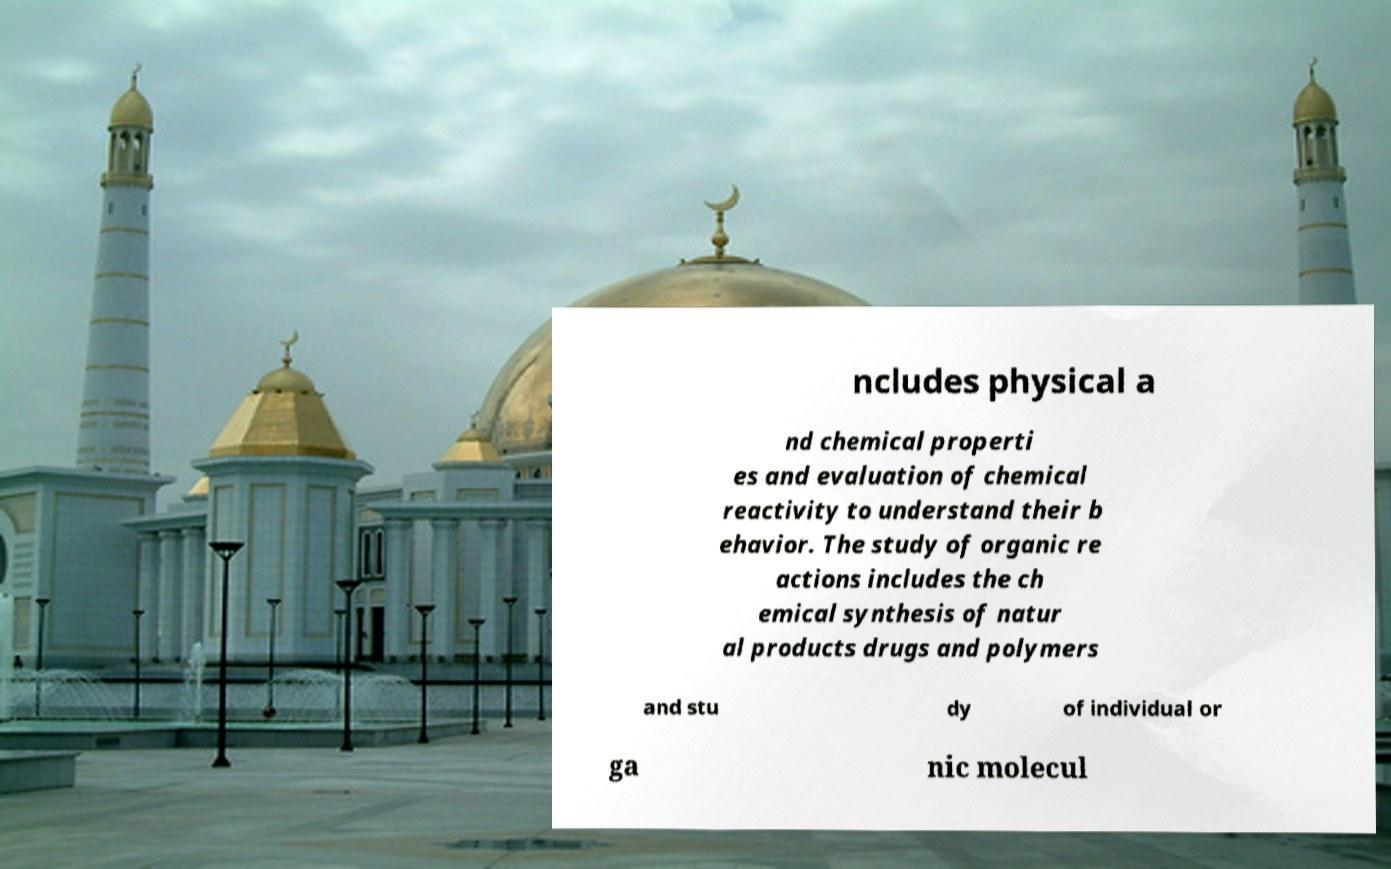Can you read and provide the text displayed in the image?This photo seems to have some interesting text. Can you extract and type it out for me? ncludes physical a nd chemical properti es and evaluation of chemical reactivity to understand their b ehavior. The study of organic re actions includes the ch emical synthesis of natur al products drugs and polymers and stu dy of individual or ga nic molecul 